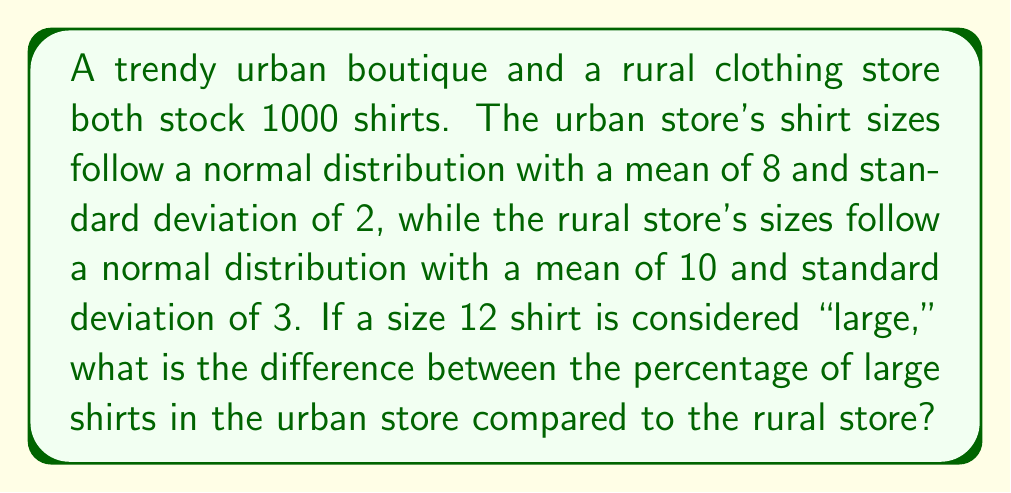What is the answer to this math problem? 1. For the urban store:
   Mean ($\mu_u$) = 8, Standard deviation ($\sigma_u$) = 2
   We need to find P(X > 12) where X is the shirt size.

   Z-score for size 12: $Z_u = \frac{12 - \mu_u}{\sigma_u} = \frac{12 - 8}{2} = 2$

   P(X > 12) = 1 - P(X ≤ 12) = 1 - Φ(2) ≈ 1 - 0.9772 = 0.0228

2. For the rural store:
   Mean ($\mu_r$) = 10, Standard deviation ($\sigma_r$) = 3
   
   Z-score for size 12: $Z_r = \frac{12 - \mu_r}{\sigma_r} = \frac{12 - 10}{3} = \frac{2}{3}$

   P(X > 12) = 1 - P(X ≤ 12) = 1 - Φ(2/3) ≈ 1 - 0.7454 = 0.2546

3. Difference in percentages:
   Rural percentage - Urban percentage = 25.46% - 2.28% = 23.18%
Answer: 23.18% 